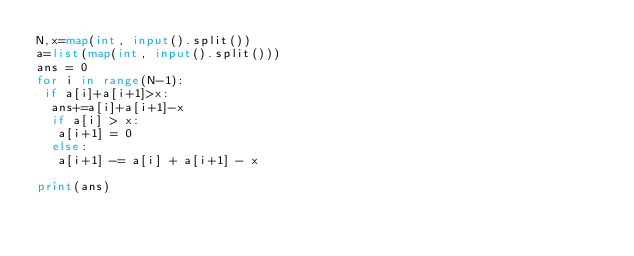<code> <loc_0><loc_0><loc_500><loc_500><_Python_>N,x=map(int, input().split())
a=list(map(int, input().split()))
ans = 0
for i in range(N-1):
 if a[i]+a[i+1]>x:
  ans+=a[i]+a[i+1]-x
  if a[i] > x:
   a[i+1] = 0
  else:
   a[i+1] -= a[i] + a[i+1] - x

print(ans)
</code> 